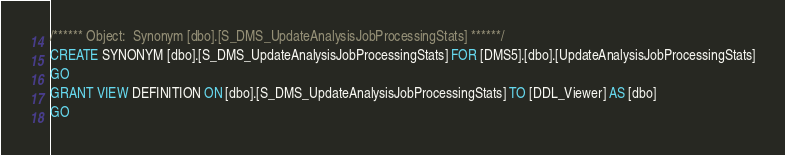Convert code to text. <code><loc_0><loc_0><loc_500><loc_500><_SQL_>/****** Object:  Synonym [dbo].[S_DMS_UpdateAnalysisJobProcessingStats] ******/
CREATE SYNONYM [dbo].[S_DMS_UpdateAnalysisJobProcessingStats] FOR [DMS5].[dbo].[UpdateAnalysisJobProcessingStats]
GO
GRANT VIEW DEFINITION ON [dbo].[S_DMS_UpdateAnalysisJobProcessingStats] TO [DDL_Viewer] AS [dbo]
GO
</code> 